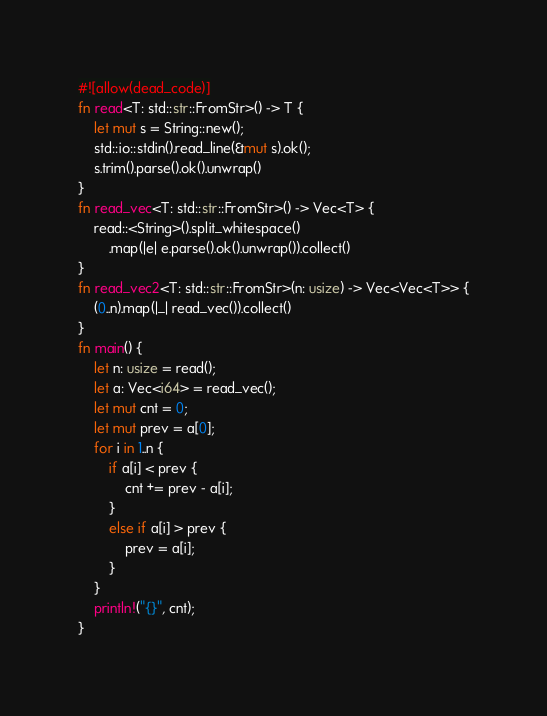<code> <loc_0><loc_0><loc_500><loc_500><_Rust_>#![allow(dead_code)]
fn read<T: std::str::FromStr>() -> T {
    let mut s = String::new();
    std::io::stdin().read_line(&mut s).ok();
    s.trim().parse().ok().unwrap()
}
fn read_vec<T: std::str::FromStr>() -> Vec<T> {
    read::<String>().split_whitespace()
        .map(|e| e.parse().ok().unwrap()).collect()
}
fn read_vec2<T: std::str::FromStr>(n: usize) -> Vec<Vec<T>> {
    (0..n).map(|_| read_vec()).collect()
}
fn main() {
    let n: usize = read();
    let a: Vec<i64> = read_vec();
    let mut cnt = 0;
    let mut prev = a[0];
    for i in 1..n {
        if a[i] < prev {
            cnt += prev - a[i];
        }
        else if a[i] > prev {
            prev = a[i];
        }
    }
    println!("{}", cnt);
}</code> 